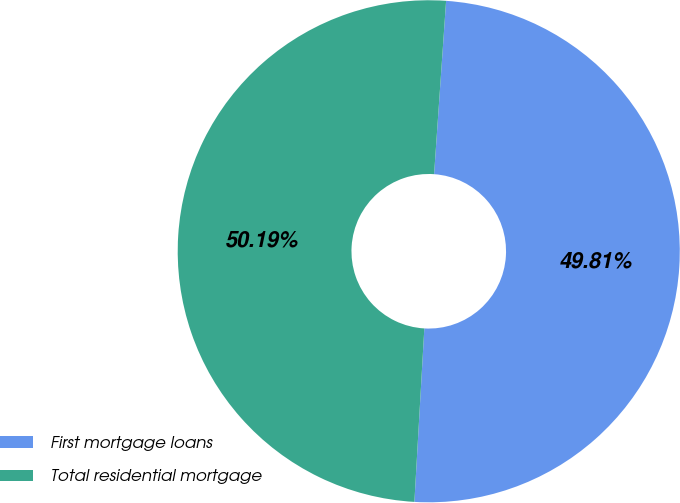Convert chart to OTSL. <chart><loc_0><loc_0><loc_500><loc_500><pie_chart><fcel>First mortgage loans<fcel>Total residential mortgage<nl><fcel>49.81%<fcel>50.19%<nl></chart> 